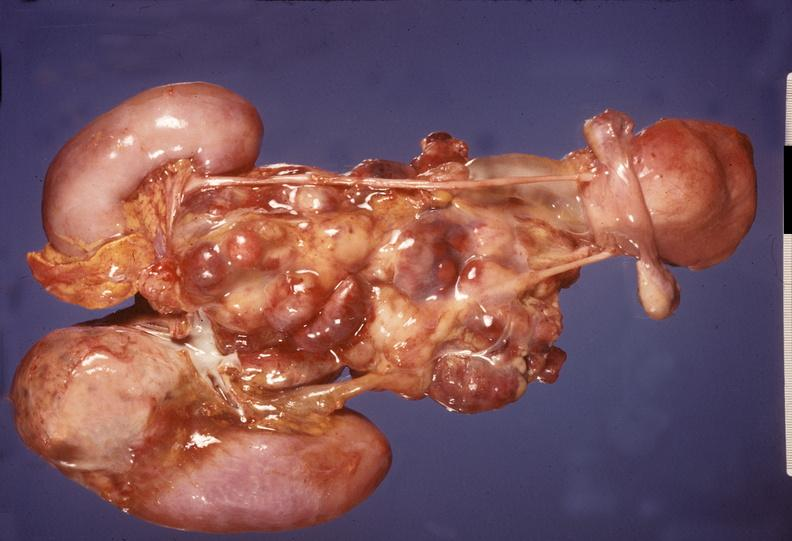what is present?
Answer the question using a single word or phrase. Endocrine 